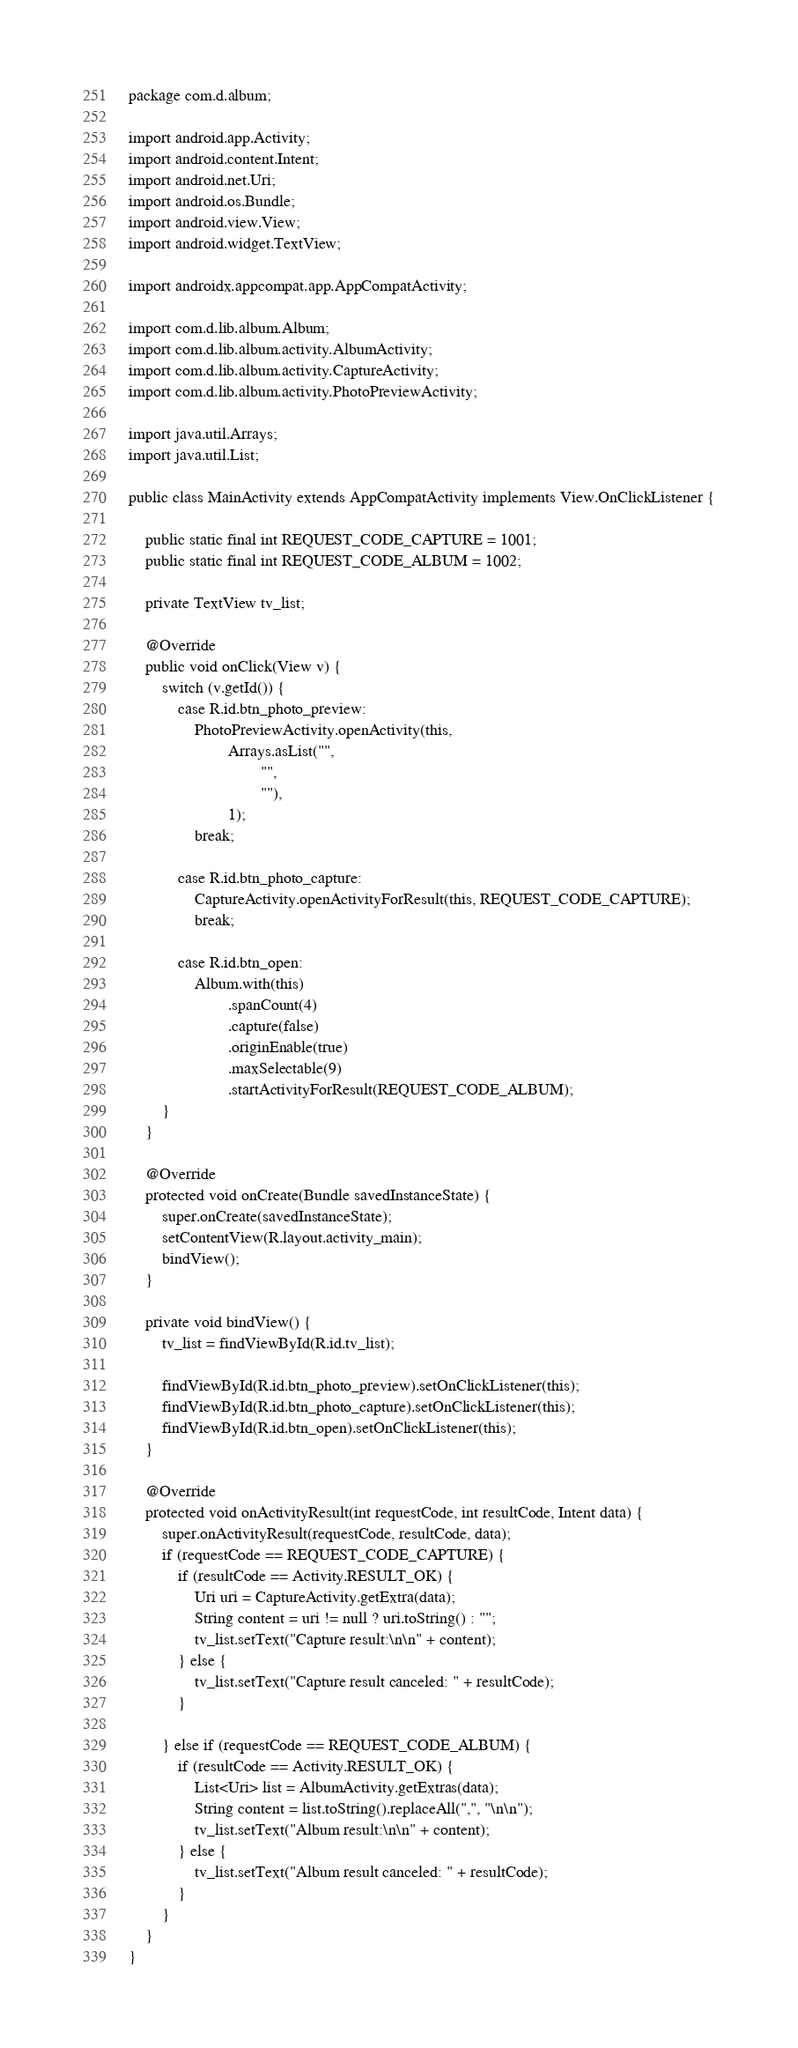Convert code to text. <code><loc_0><loc_0><loc_500><loc_500><_Java_>package com.d.album;

import android.app.Activity;
import android.content.Intent;
import android.net.Uri;
import android.os.Bundle;
import android.view.View;
import android.widget.TextView;

import androidx.appcompat.app.AppCompatActivity;

import com.d.lib.album.Album;
import com.d.lib.album.activity.AlbumActivity;
import com.d.lib.album.activity.CaptureActivity;
import com.d.lib.album.activity.PhotoPreviewActivity;

import java.util.Arrays;
import java.util.List;

public class MainActivity extends AppCompatActivity implements View.OnClickListener {

    public static final int REQUEST_CODE_CAPTURE = 1001;
    public static final int REQUEST_CODE_ALBUM = 1002;

    private TextView tv_list;

    @Override
    public void onClick(View v) {
        switch (v.getId()) {
            case R.id.btn_photo_preview:
                PhotoPreviewActivity.openActivity(this,
                        Arrays.asList("",
                                "",
                                ""),
                        1);
                break;

            case R.id.btn_photo_capture:
                CaptureActivity.openActivityForResult(this, REQUEST_CODE_CAPTURE);
                break;

            case R.id.btn_open:
                Album.with(this)
                        .spanCount(4)
                        .capture(false)
                        .originEnable(true)
                        .maxSelectable(9)
                        .startActivityForResult(REQUEST_CODE_ALBUM);
        }
    }

    @Override
    protected void onCreate(Bundle savedInstanceState) {
        super.onCreate(savedInstanceState);
        setContentView(R.layout.activity_main);
        bindView();
    }

    private void bindView() {
        tv_list = findViewById(R.id.tv_list);

        findViewById(R.id.btn_photo_preview).setOnClickListener(this);
        findViewById(R.id.btn_photo_capture).setOnClickListener(this);
        findViewById(R.id.btn_open).setOnClickListener(this);
    }

    @Override
    protected void onActivityResult(int requestCode, int resultCode, Intent data) {
        super.onActivityResult(requestCode, resultCode, data);
        if (requestCode == REQUEST_CODE_CAPTURE) {
            if (resultCode == Activity.RESULT_OK) {
                Uri uri = CaptureActivity.getExtra(data);
                String content = uri != null ? uri.toString() : "";
                tv_list.setText("Capture result:\n\n" + content);
            } else {
                tv_list.setText("Capture result canceled: " + resultCode);
            }

        } else if (requestCode == REQUEST_CODE_ALBUM) {
            if (resultCode == Activity.RESULT_OK) {
                List<Uri> list = AlbumActivity.getExtras(data);
                String content = list.toString().replaceAll(",", "\n\n");
                tv_list.setText("Album result:\n\n" + content);
            } else {
                tv_list.setText("Album result canceled: " + resultCode);
            }
        }
    }
}
</code> 